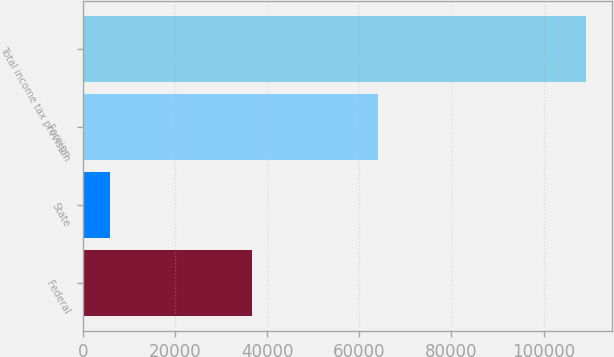Convert chart. <chart><loc_0><loc_0><loc_500><loc_500><bar_chart><fcel>Federal<fcel>State<fcel>Foreign<fcel>Total income tax provision<nl><fcel>36771<fcel>5785<fcel>64109<fcel>109331<nl></chart> 